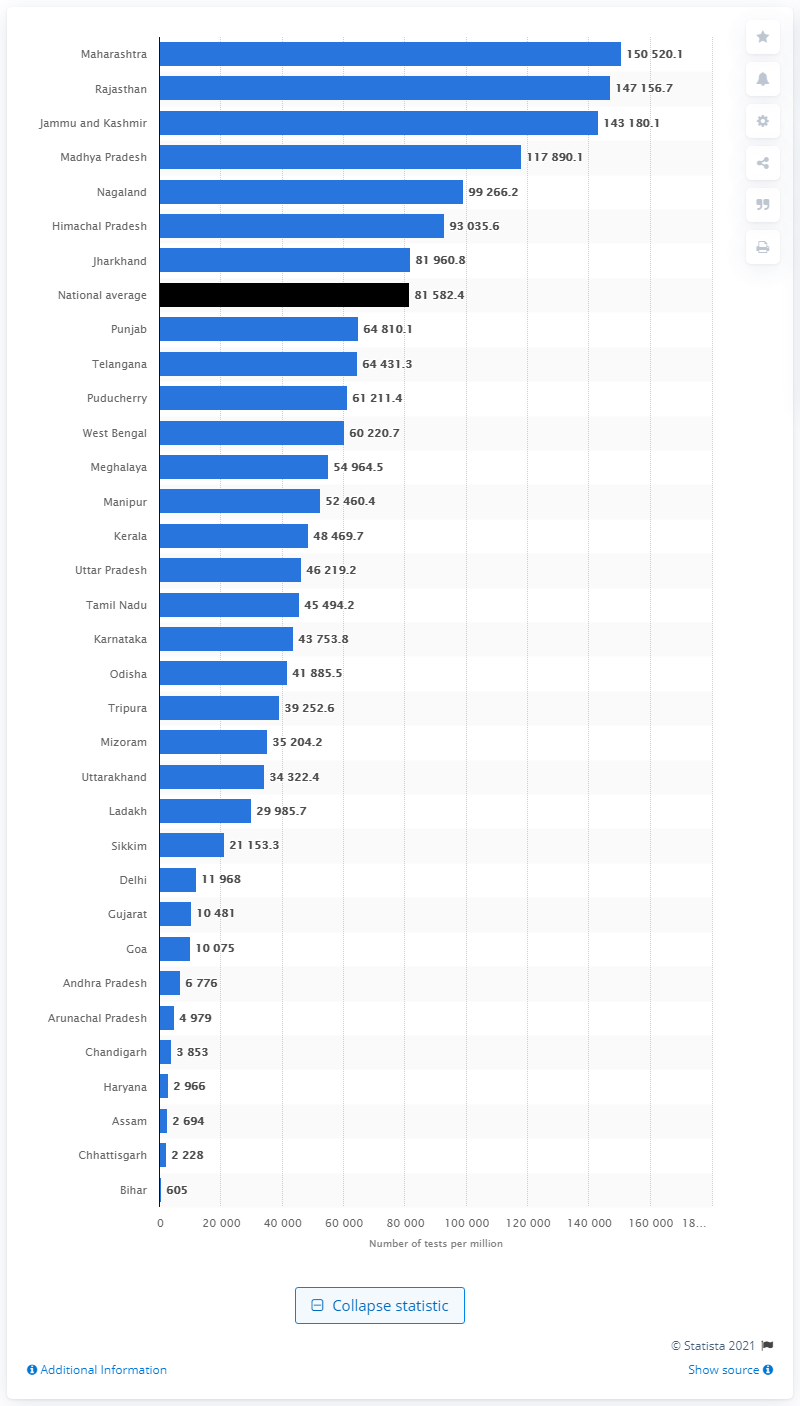Outline some significant characteristics in this image. The lowest rate of COVID-19 testing in Bihar was 605 per 100,000 people. According to the latest data, Maharashtra recorded the highest number of COVID-19 tests conducted in a state in India. 